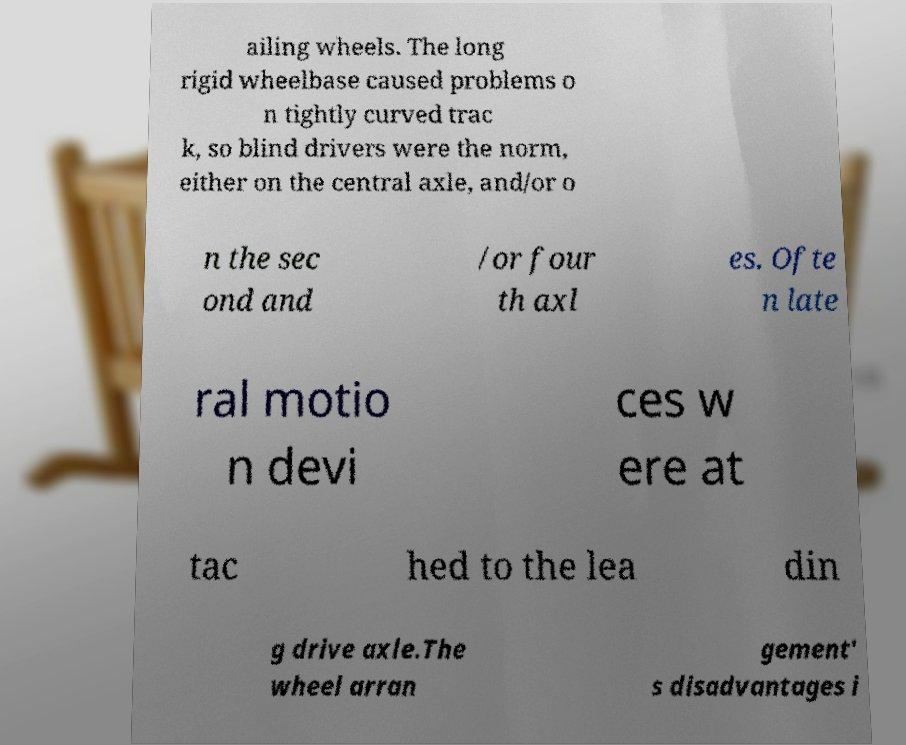Can you read and provide the text displayed in the image?This photo seems to have some interesting text. Can you extract and type it out for me? ailing wheels. The long rigid wheelbase caused problems o n tightly curved trac k, so blind drivers were the norm, either on the central axle, and/or o n the sec ond and /or four th axl es. Ofte n late ral motio n devi ces w ere at tac hed to the lea din g drive axle.The wheel arran gement' s disadvantages i 